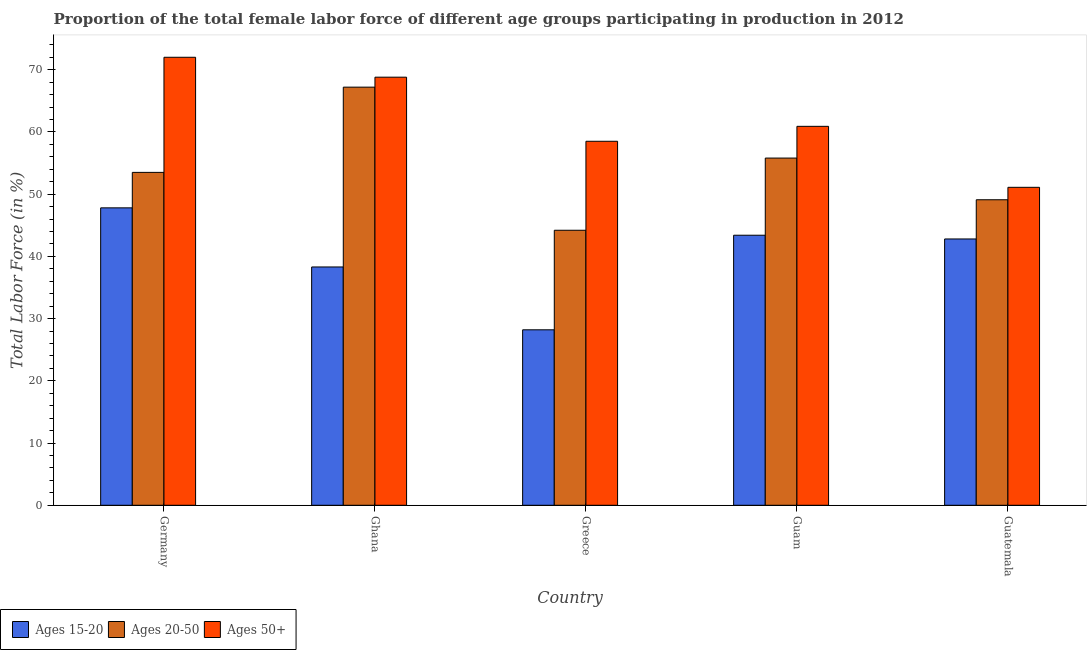How many groups of bars are there?
Provide a succinct answer. 5. Are the number of bars per tick equal to the number of legend labels?
Keep it short and to the point. Yes. Are the number of bars on each tick of the X-axis equal?
Offer a terse response. Yes. How many bars are there on the 4th tick from the right?
Ensure brevity in your answer.  3. What is the label of the 4th group of bars from the left?
Offer a terse response. Guam. What is the percentage of female labor force within the age group 15-20 in Guam?
Your answer should be very brief. 43.4. Across all countries, what is the maximum percentage of female labor force within the age group 20-50?
Provide a short and direct response. 67.2. Across all countries, what is the minimum percentage of female labor force above age 50?
Make the answer very short. 51.1. In which country was the percentage of female labor force within the age group 20-50 maximum?
Offer a terse response. Ghana. In which country was the percentage of female labor force within the age group 15-20 minimum?
Your answer should be very brief. Greece. What is the total percentage of female labor force within the age group 15-20 in the graph?
Your answer should be compact. 200.5. What is the difference between the percentage of female labor force above age 50 in Guam and that in Guatemala?
Keep it short and to the point. 9.8. What is the difference between the percentage of female labor force within the age group 20-50 in Guatemala and the percentage of female labor force above age 50 in Guam?
Give a very brief answer. -11.8. What is the average percentage of female labor force within the age group 15-20 per country?
Make the answer very short. 40.1. What is the difference between the percentage of female labor force above age 50 and percentage of female labor force within the age group 15-20 in Germany?
Provide a short and direct response. 24.2. In how many countries, is the percentage of female labor force above age 50 greater than 20 %?
Your answer should be compact. 5. What is the ratio of the percentage of female labor force within the age group 20-50 in Greece to that in Guatemala?
Offer a terse response. 0.9. Is the percentage of female labor force above age 50 in Ghana less than that in Guam?
Give a very brief answer. No. Is the difference between the percentage of female labor force within the age group 20-50 in Greece and Guatemala greater than the difference between the percentage of female labor force within the age group 15-20 in Greece and Guatemala?
Your answer should be very brief. Yes. What is the difference between the highest and the second highest percentage of female labor force within the age group 15-20?
Provide a succinct answer. 4.4. What is the difference between the highest and the lowest percentage of female labor force within the age group 20-50?
Ensure brevity in your answer.  23. What does the 3rd bar from the left in Guam represents?
Offer a very short reply. Ages 50+. What does the 1st bar from the right in Ghana represents?
Your answer should be compact. Ages 50+. Is it the case that in every country, the sum of the percentage of female labor force within the age group 15-20 and percentage of female labor force within the age group 20-50 is greater than the percentage of female labor force above age 50?
Your answer should be very brief. Yes. Are all the bars in the graph horizontal?
Your answer should be compact. No. How many countries are there in the graph?
Provide a succinct answer. 5. Does the graph contain any zero values?
Your response must be concise. No. Does the graph contain grids?
Offer a very short reply. No. How many legend labels are there?
Make the answer very short. 3. What is the title of the graph?
Provide a succinct answer. Proportion of the total female labor force of different age groups participating in production in 2012. What is the label or title of the Y-axis?
Your answer should be compact. Total Labor Force (in %). What is the Total Labor Force (in %) of Ages 15-20 in Germany?
Your response must be concise. 47.8. What is the Total Labor Force (in %) in Ages 20-50 in Germany?
Give a very brief answer. 53.5. What is the Total Labor Force (in %) of Ages 50+ in Germany?
Keep it short and to the point. 72. What is the Total Labor Force (in %) of Ages 15-20 in Ghana?
Offer a terse response. 38.3. What is the Total Labor Force (in %) of Ages 20-50 in Ghana?
Your answer should be compact. 67.2. What is the Total Labor Force (in %) in Ages 50+ in Ghana?
Your answer should be compact. 68.8. What is the Total Labor Force (in %) of Ages 15-20 in Greece?
Give a very brief answer. 28.2. What is the Total Labor Force (in %) of Ages 20-50 in Greece?
Your response must be concise. 44.2. What is the Total Labor Force (in %) of Ages 50+ in Greece?
Your response must be concise. 58.5. What is the Total Labor Force (in %) of Ages 15-20 in Guam?
Make the answer very short. 43.4. What is the Total Labor Force (in %) of Ages 20-50 in Guam?
Keep it short and to the point. 55.8. What is the Total Labor Force (in %) in Ages 50+ in Guam?
Keep it short and to the point. 60.9. What is the Total Labor Force (in %) in Ages 15-20 in Guatemala?
Provide a succinct answer. 42.8. What is the Total Labor Force (in %) in Ages 20-50 in Guatemala?
Give a very brief answer. 49.1. What is the Total Labor Force (in %) in Ages 50+ in Guatemala?
Give a very brief answer. 51.1. Across all countries, what is the maximum Total Labor Force (in %) in Ages 15-20?
Keep it short and to the point. 47.8. Across all countries, what is the maximum Total Labor Force (in %) in Ages 20-50?
Offer a terse response. 67.2. Across all countries, what is the maximum Total Labor Force (in %) in Ages 50+?
Your response must be concise. 72. Across all countries, what is the minimum Total Labor Force (in %) in Ages 15-20?
Offer a terse response. 28.2. Across all countries, what is the minimum Total Labor Force (in %) of Ages 20-50?
Your answer should be compact. 44.2. Across all countries, what is the minimum Total Labor Force (in %) of Ages 50+?
Make the answer very short. 51.1. What is the total Total Labor Force (in %) of Ages 15-20 in the graph?
Give a very brief answer. 200.5. What is the total Total Labor Force (in %) in Ages 20-50 in the graph?
Keep it short and to the point. 269.8. What is the total Total Labor Force (in %) of Ages 50+ in the graph?
Give a very brief answer. 311.3. What is the difference between the Total Labor Force (in %) of Ages 20-50 in Germany and that in Ghana?
Your response must be concise. -13.7. What is the difference between the Total Labor Force (in %) in Ages 15-20 in Germany and that in Greece?
Give a very brief answer. 19.6. What is the difference between the Total Labor Force (in %) of Ages 50+ in Germany and that in Greece?
Your answer should be very brief. 13.5. What is the difference between the Total Labor Force (in %) of Ages 15-20 in Germany and that in Guam?
Offer a terse response. 4.4. What is the difference between the Total Labor Force (in %) of Ages 20-50 in Germany and that in Guam?
Your answer should be very brief. -2.3. What is the difference between the Total Labor Force (in %) of Ages 50+ in Germany and that in Guatemala?
Make the answer very short. 20.9. What is the difference between the Total Labor Force (in %) in Ages 15-20 in Ghana and that in Guam?
Your answer should be compact. -5.1. What is the difference between the Total Labor Force (in %) in Ages 50+ in Ghana and that in Guatemala?
Keep it short and to the point. 17.7. What is the difference between the Total Labor Force (in %) in Ages 15-20 in Greece and that in Guam?
Give a very brief answer. -15.2. What is the difference between the Total Labor Force (in %) in Ages 15-20 in Greece and that in Guatemala?
Make the answer very short. -14.6. What is the difference between the Total Labor Force (in %) of Ages 20-50 in Greece and that in Guatemala?
Your response must be concise. -4.9. What is the difference between the Total Labor Force (in %) of Ages 50+ in Greece and that in Guatemala?
Provide a short and direct response. 7.4. What is the difference between the Total Labor Force (in %) of Ages 15-20 in Guam and that in Guatemala?
Offer a very short reply. 0.6. What is the difference between the Total Labor Force (in %) in Ages 50+ in Guam and that in Guatemala?
Offer a very short reply. 9.8. What is the difference between the Total Labor Force (in %) of Ages 15-20 in Germany and the Total Labor Force (in %) of Ages 20-50 in Ghana?
Provide a short and direct response. -19.4. What is the difference between the Total Labor Force (in %) of Ages 15-20 in Germany and the Total Labor Force (in %) of Ages 50+ in Ghana?
Your answer should be very brief. -21. What is the difference between the Total Labor Force (in %) in Ages 20-50 in Germany and the Total Labor Force (in %) in Ages 50+ in Ghana?
Provide a short and direct response. -15.3. What is the difference between the Total Labor Force (in %) in Ages 15-20 in Germany and the Total Labor Force (in %) in Ages 20-50 in Greece?
Give a very brief answer. 3.6. What is the difference between the Total Labor Force (in %) in Ages 15-20 in Germany and the Total Labor Force (in %) in Ages 50+ in Greece?
Provide a succinct answer. -10.7. What is the difference between the Total Labor Force (in %) in Ages 20-50 in Germany and the Total Labor Force (in %) in Ages 50+ in Greece?
Provide a succinct answer. -5. What is the difference between the Total Labor Force (in %) in Ages 15-20 in Germany and the Total Labor Force (in %) in Ages 20-50 in Guam?
Provide a succinct answer. -8. What is the difference between the Total Labor Force (in %) of Ages 15-20 in Germany and the Total Labor Force (in %) of Ages 20-50 in Guatemala?
Offer a very short reply. -1.3. What is the difference between the Total Labor Force (in %) of Ages 15-20 in Germany and the Total Labor Force (in %) of Ages 50+ in Guatemala?
Offer a very short reply. -3.3. What is the difference between the Total Labor Force (in %) of Ages 15-20 in Ghana and the Total Labor Force (in %) of Ages 50+ in Greece?
Keep it short and to the point. -20.2. What is the difference between the Total Labor Force (in %) of Ages 15-20 in Ghana and the Total Labor Force (in %) of Ages 20-50 in Guam?
Offer a terse response. -17.5. What is the difference between the Total Labor Force (in %) of Ages 15-20 in Ghana and the Total Labor Force (in %) of Ages 50+ in Guam?
Offer a very short reply. -22.6. What is the difference between the Total Labor Force (in %) in Ages 15-20 in Ghana and the Total Labor Force (in %) in Ages 20-50 in Guatemala?
Make the answer very short. -10.8. What is the difference between the Total Labor Force (in %) of Ages 15-20 in Greece and the Total Labor Force (in %) of Ages 20-50 in Guam?
Give a very brief answer. -27.6. What is the difference between the Total Labor Force (in %) in Ages 15-20 in Greece and the Total Labor Force (in %) in Ages 50+ in Guam?
Your answer should be compact. -32.7. What is the difference between the Total Labor Force (in %) in Ages 20-50 in Greece and the Total Labor Force (in %) in Ages 50+ in Guam?
Give a very brief answer. -16.7. What is the difference between the Total Labor Force (in %) in Ages 15-20 in Greece and the Total Labor Force (in %) in Ages 20-50 in Guatemala?
Provide a short and direct response. -20.9. What is the difference between the Total Labor Force (in %) of Ages 15-20 in Greece and the Total Labor Force (in %) of Ages 50+ in Guatemala?
Your answer should be very brief. -22.9. What is the difference between the Total Labor Force (in %) in Ages 20-50 in Greece and the Total Labor Force (in %) in Ages 50+ in Guatemala?
Your answer should be very brief. -6.9. What is the average Total Labor Force (in %) of Ages 15-20 per country?
Your answer should be compact. 40.1. What is the average Total Labor Force (in %) of Ages 20-50 per country?
Offer a very short reply. 53.96. What is the average Total Labor Force (in %) in Ages 50+ per country?
Give a very brief answer. 62.26. What is the difference between the Total Labor Force (in %) in Ages 15-20 and Total Labor Force (in %) in Ages 20-50 in Germany?
Make the answer very short. -5.7. What is the difference between the Total Labor Force (in %) of Ages 15-20 and Total Labor Force (in %) of Ages 50+ in Germany?
Keep it short and to the point. -24.2. What is the difference between the Total Labor Force (in %) in Ages 20-50 and Total Labor Force (in %) in Ages 50+ in Germany?
Offer a very short reply. -18.5. What is the difference between the Total Labor Force (in %) of Ages 15-20 and Total Labor Force (in %) of Ages 20-50 in Ghana?
Offer a very short reply. -28.9. What is the difference between the Total Labor Force (in %) in Ages 15-20 and Total Labor Force (in %) in Ages 50+ in Ghana?
Offer a terse response. -30.5. What is the difference between the Total Labor Force (in %) of Ages 15-20 and Total Labor Force (in %) of Ages 50+ in Greece?
Ensure brevity in your answer.  -30.3. What is the difference between the Total Labor Force (in %) in Ages 20-50 and Total Labor Force (in %) in Ages 50+ in Greece?
Your response must be concise. -14.3. What is the difference between the Total Labor Force (in %) of Ages 15-20 and Total Labor Force (in %) of Ages 50+ in Guam?
Ensure brevity in your answer.  -17.5. What is the ratio of the Total Labor Force (in %) in Ages 15-20 in Germany to that in Ghana?
Make the answer very short. 1.25. What is the ratio of the Total Labor Force (in %) of Ages 20-50 in Germany to that in Ghana?
Offer a terse response. 0.8. What is the ratio of the Total Labor Force (in %) of Ages 50+ in Germany to that in Ghana?
Keep it short and to the point. 1.05. What is the ratio of the Total Labor Force (in %) in Ages 15-20 in Germany to that in Greece?
Make the answer very short. 1.7. What is the ratio of the Total Labor Force (in %) of Ages 20-50 in Germany to that in Greece?
Your answer should be compact. 1.21. What is the ratio of the Total Labor Force (in %) in Ages 50+ in Germany to that in Greece?
Offer a terse response. 1.23. What is the ratio of the Total Labor Force (in %) in Ages 15-20 in Germany to that in Guam?
Provide a succinct answer. 1.1. What is the ratio of the Total Labor Force (in %) in Ages 20-50 in Germany to that in Guam?
Offer a very short reply. 0.96. What is the ratio of the Total Labor Force (in %) in Ages 50+ in Germany to that in Guam?
Ensure brevity in your answer.  1.18. What is the ratio of the Total Labor Force (in %) in Ages 15-20 in Germany to that in Guatemala?
Provide a short and direct response. 1.12. What is the ratio of the Total Labor Force (in %) of Ages 20-50 in Germany to that in Guatemala?
Your response must be concise. 1.09. What is the ratio of the Total Labor Force (in %) of Ages 50+ in Germany to that in Guatemala?
Ensure brevity in your answer.  1.41. What is the ratio of the Total Labor Force (in %) in Ages 15-20 in Ghana to that in Greece?
Your answer should be very brief. 1.36. What is the ratio of the Total Labor Force (in %) of Ages 20-50 in Ghana to that in Greece?
Offer a very short reply. 1.52. What is the ratio of the Total Labor Force (in %) in Ages 50+ in Ghana to that in Greece?
Your answer should be compact. 1.18. What is the ratio of the Total Labor Force (in %) in Ages 15-20 in Ghana to that in Guam?
Your answer should be very brief. 0.88. What is the ratio of the Total Labor Force (in %) of Ages 20-50 in Ghana to that in Guam?
Make the answer very short. 1.2. What is the ratio of the Total Labor Force (in %) in Ages 50+ in Ghana to that in Guam?
Your answer should be compact. 1.13. What is the ratio of the Total Labor Force (in %) of Ages 15-20 in Ghana to that in Guatemala?
Offer a very short reply. 0.89. What is the ratio of the Total Labor Force (in %) of Ages 20-50 in Ghana to that in Guatemala?
Keep it short and to the point. 1.37. What is the ratio of the Total Labor Force (in %) in Ages 50+ in Ghana to that in Guatemala?
Offer a very short reply. 1.35. What is the ratio of the Total Labor Force (in %) in Ages 15-20 in Greece to that in Guam?
Your answer should be very brief. 0.65. What is the ratio of the Total Labor Force (in %) in Ages 20-50 in Greece to that in Guam?
Give a very brief answer. 0.79. What is the ratio of the Total Labor Force (in %) of Ages 50+ in Greece to that in Guam?
Give a very brief answer. 0.96. What is the ratio of the Total Labor Force (in %) in Ages 15-20 in Greece to that in Guatemala?
Make the answer very short. 0.66. What is the ratio of the Total Labor Force (in %) in Ages 20-50 in Greece to that in Guatemala?
Provide a short and direct response. 0.9. What is the ratio of the Total Labor Force (in %) of Ages 50+ in Greece to that in Guatemala?
Give a very brief answer. 1.14. What is the ratio of the Total Labor Force (in %) in Ages 15-20 in Guam to that in Guatemala?
Keep it short and to the point. 1.01. What is the ratio of the Total Labor Force (in %) in Ages 20-50 in Guam to that in Guatemala?
Offer a terse response. 1.14. What is the ratio of the Total Labor Force (in %) of Ages 50+ in Guam to that in Guatemala?
Make the answer very short. 1.19. What is the difference between the highest and the lowest Total Labor Force (in %) of Ages 15-20?
Ensure brevity in your answer.  19.6. What is the difference between the highest and the lowest Total Labor Force (in %) in Ages 20-50?
Provide a succinct answer. 23. What is the difference between the highest and the lowest Total Labor Force (in %) in Ages 50+?
Provide a short and direct response. 20.9. 